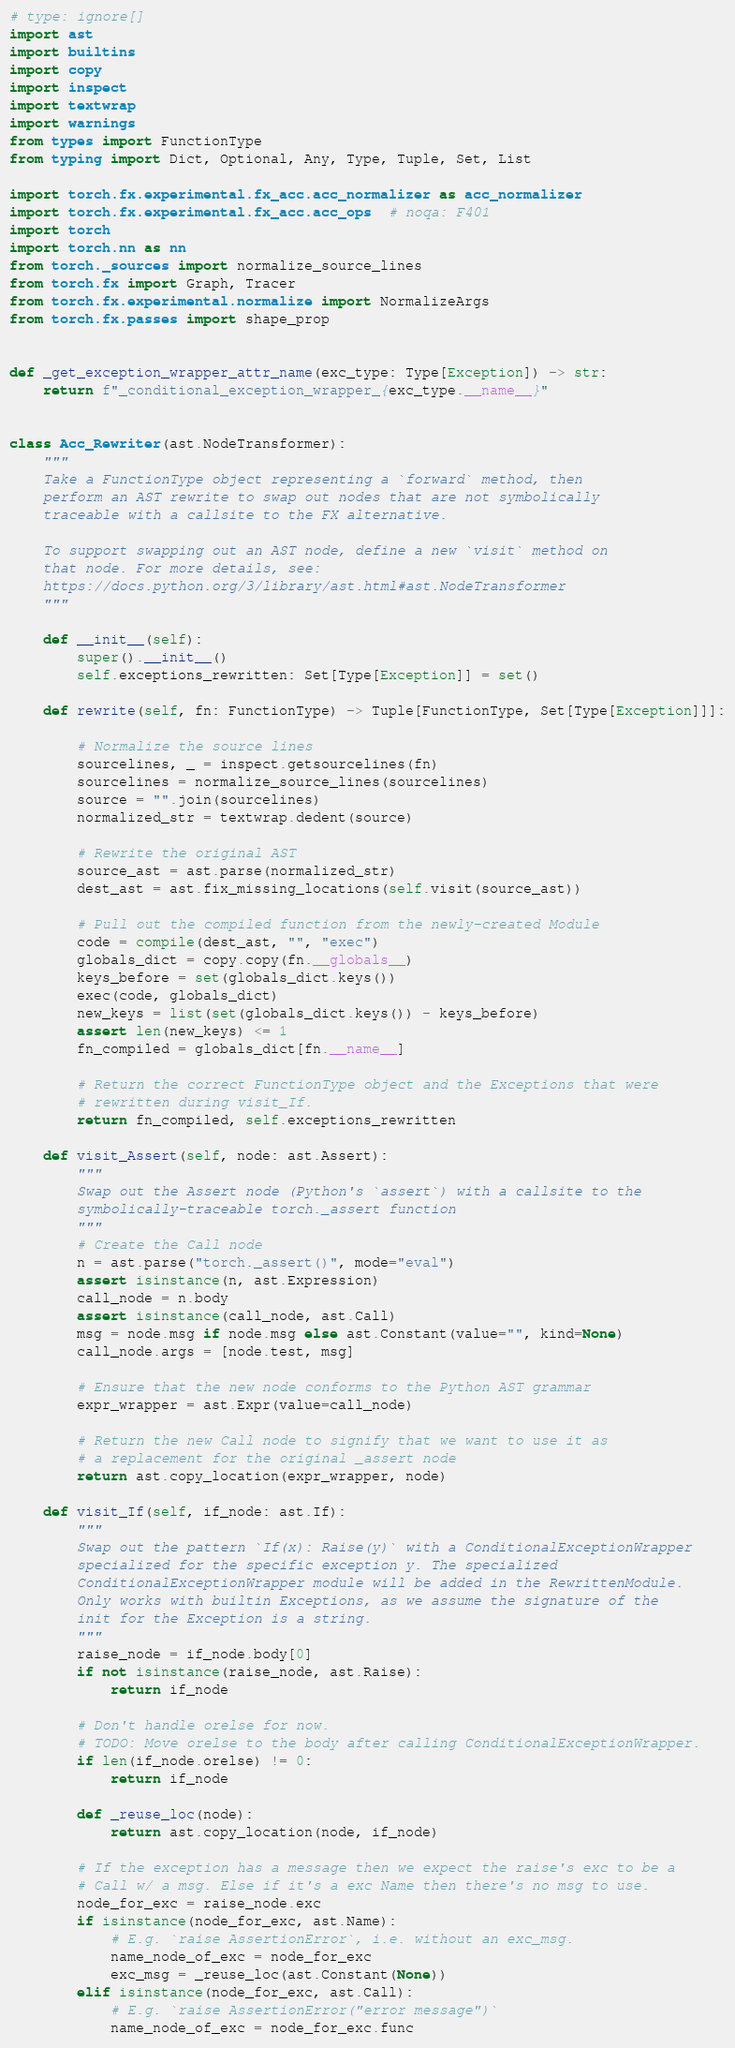Convert code to text. <code><loc_0><loc_0><loc_500><loc_500><_Python_># type: ignore[]
import ast
import builtins
import copy
import inspect
import textwrap
import warnings
from types import FunctionType
from typing import Dict, Optional, Any, Type, Tuple, Set, List

import torch.fx.experimental.fx_acc.acc_normalizer as acc_normalizer
import torch.fx.experimental.fx_acc.acc_ops  # noqa: F401
import torch
import torch.nn as nn
from torch._sources import normalize_source_lines
from torch.fx import Graph, Tracer
from torch.fx.experimental.normalize import NormalizeArgs
from torch.fx.passes import shape_prop


def _get_exception_wrapper_attr_name(exc_type: Type[Exception]) -> str:
    return f"_conditional_exception_wrapper_{exc_type.__name__}"


class Acc_Rewriter(ast.NodeTransformer):
    """
    Take a FunctionType object representing a `forward` method, then
    perform an AST rewrite to swap out nodes that are not symbolically
    traceable with a callsite to the FX alternative.

    To support swapping out an AST node, define a new `visit` method on
    that node. For more details, see:
    https://docs.python.org/3/library/ast.html#ast.NodeTransformer
    """

    def __init__(self):
        super().__init__()
        self.exceptions_rewritten: Set[Type[Exception]] = set()

    def rewrite(self, fn: FunctionType) -> Tuple[FunctionType, Set[Type[Exception]]]:

        # Normalize the source lines
        sourcelines, _ = inspect.getsourcelines(fn)
        sourcelines = normalize_source_lines(sourcelines)
        source = "".join(sourcelines)
        normalized_str = textwrap.dedent(source)

        # Rewrite the original AST
        source_ast = ast.parse(normalized_str)
        dest_ast = ast.fix_missing_locations(self.visit(source_ast))

        # Pull out the compiled function from the newly-created Module
        code = compile(dest_ast, "", "exec")
        globals_dict = copy.copy(fn.__globals__)
        keys_before = set(globals_dict.keys())
        exec(code, globals_dict)
        new_keys = list(set(globals_dict.keys()) - keys_before)
        assert len(new_keys) <= 1
        fn_compiled = globals_dict[fn.__name__]

        # Return the correct FunctionType object and the Exceptions that were
        # rewritten during visit_If.
        return fn_compiled, self.exceptions_rewritten

    def visit_Assert(self, node: ast.Assert):
        """
        Swap out the Assert node (Python's `assert`) with a callsite to the
        symbolically-traceable torch._assert function
        """
        # Create the Call node
        n = ast.parse("torch._assert()", mode="eval")
        assert isinstance(n, ast.Expression)
        call_node = n.body
        assert isinstance(call_node, ast.Call)
        msg = node.msg if node.msg else ast.Constant(value="", kind=None)
        call_node.args = [node.test, msg]

        # Ensure that the new node conforms to the Python AST grammar
        expr_wrapper = ast.Expr(value=call_node)

        # Return the new Call node to signify that we want to use it as
        # a replacement for the original _assert node
        return ast.copy_location(expr_wrapper, node)

    def visit_If(self, if_node: ast.If):
        """
        Swap out the pattern `If(x): Raise(y)` with a ConditionalExceptionWrapper
        specialized for the specific exception y. The specialized
        ConditionalExceptionWrapper module will be added in the RewrittenModule.
        Only works with builtin Exceptions, as we assume the signature of the
        init for the Exception is a string.
        """
        raise_node = if_node.body[0]
        if not isinstance(raise_node, ast.Raise):
            return if_node

        # Don't handle orelse for now.
        # TODO: Move orelse to the body after calling ConditionalExceptionWrapper.
        if len(if_node.orelse) != 0:
            return if_node

        def _reuse_loc(node):
            return ast.copy_location(node, if_node)

        # If the exception has a message then we expect the raise's exc to be a
        # Call w/ a msg. Else if it's a exc Name then there's no msg to use.
        node_for_exc = raise_node.exc
        if isinstance(node_for_exc, ast.Name):
            # E.g. `raise AssertionError`, i.e. without an exc_msg.
            name_node_of_exc = node_for_exc
            exc_msg = _reuse_loc(ast.Constant(None))
        elif isinstance(node_for_exc, ast.Call):
            # E.g. `raise AssertionError("error message")`
            name_node_of_exc = node_for_exc.func</code> 